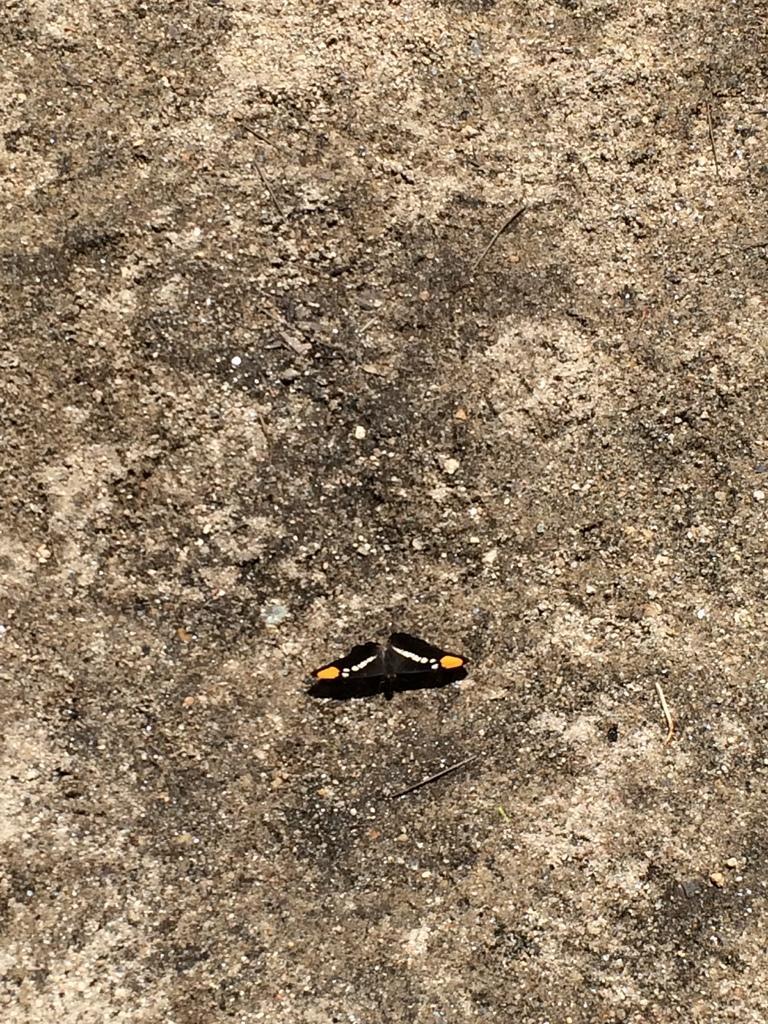What type of creature is in the image? There is an insect in the image. What colors can be seen on the insect? The insect has black, white, and yellow colors. Where is the insect located in the image? The insect is on a rock. What type of jellyfish can be seen floating in the water in the image? There is no jellyfish present in the image; it features an insect on a rock. How does the popcorn smell in the image? There is no popcorn present in the image, so it cannot be determined how it might smell. 